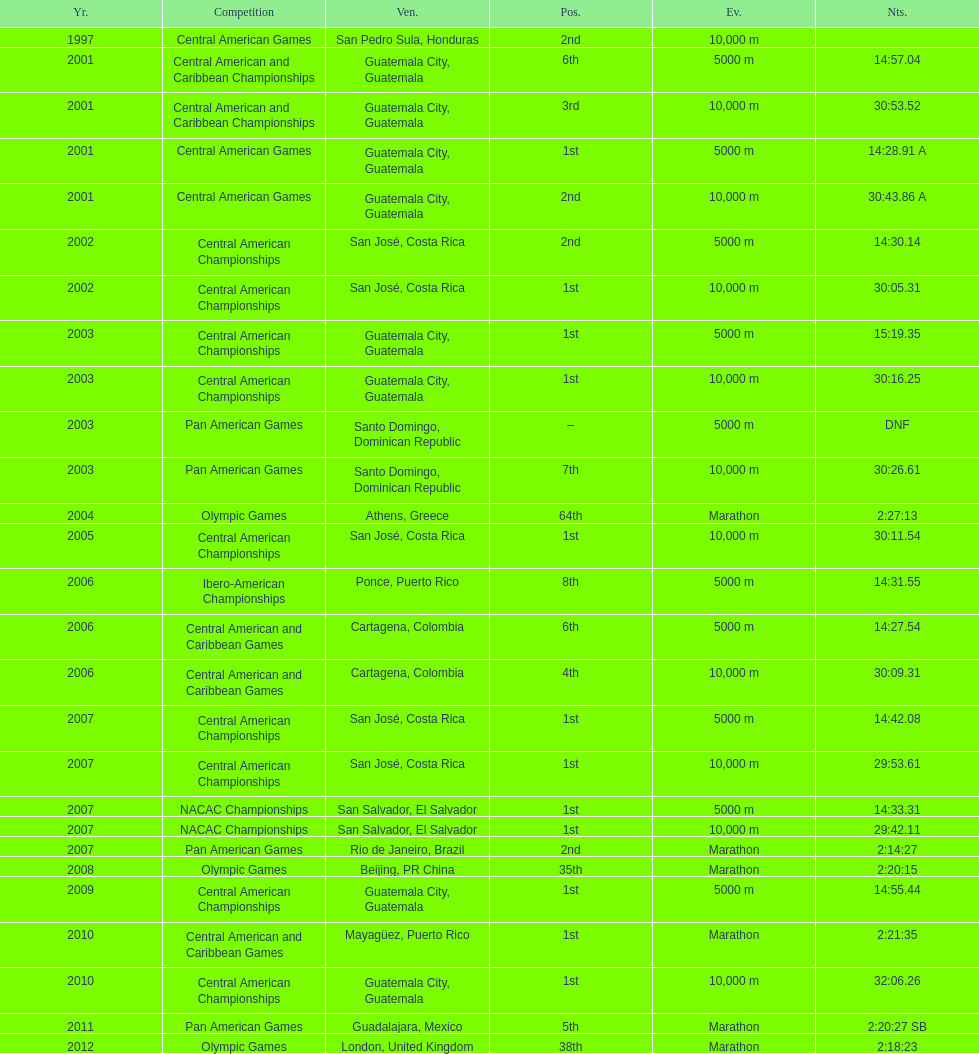Which event is listed more between the 10,000m and the 5000m? 10,000 m. 